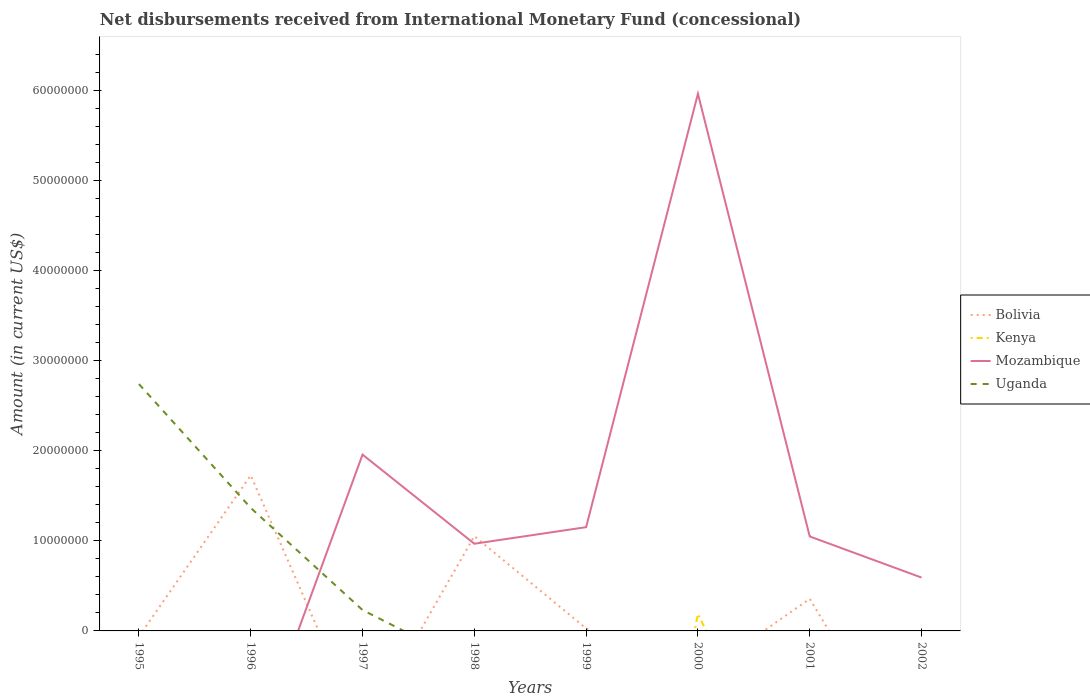What is the total amount of disbursements received from International Monetary Fund in Mozambique in the graph?
Offer a terse response. 9.89e+06. What is the difference between the highest and the second highest amount of disbursements received from International Monetary Fund in Bolivia?
Keep it short and to the point. 1.73e+07. What is the difference between the highest and the lowest amount of disbursements received from International Monetary Fund in Kenya?
Your answer should be compact. 1. Is the amount of disbursements received from International Monetary Fund in Kenya strictly greater than the amount of disbursements received from International Monetary Fund in Bolivia over the years?
Offer a very short reply. No. How many lines are there?
Your answer should be very brief. 4. How many years are there in the graph?
Ensure brevity in your answer.  8. What is the difference between two consecutive major ticks on the Y-axis?
Your answer should be compact. 1.00e+07. Are the values on the major ticks of Y-axis written in scientific E-notation?
Ensure brevity in your answer.  No. Does the graph contain grids?
Provide a succinct answer. No. How many legend labels are there?
Your answer should be very brief. 4. What is the title of the graph?
Offer a terse response. Net disbursements received from International Monetary Fund (concessional). What is the label or title of the X-axis?
Keep it short and to the point. Years. What is the label or title of the Y-axis?
Give a very brief answer. Amount (in current US$). What is the Amount (in current US$) in Bolivia in 1995?
Keep it short and to the point. 0. What is the Amount (in current US$) in Kenya in 1995?
Offer a very short reply. 0. What is the Amount (in current US$) in Mozambique in 1995?
Your answer should be very brief. 0. What is the Amount (in current US$) of Uganda in 1995?
Keep it short and to the point. 2.74e+07. What is the Amount (in current US$) in Bolivia in 1996?
Offer a very short reply. 1.73e+07. What is the Amount (in current US$) of Uganda in 1996?
Provide a succinct answer. 1.37e+07. What is the Amount (in current US$) of Bolivia in 1997?
Your answer should be compact. 0. What is the Amount (in current US$) in Mozambique in 1997?
Provide a succinct answer. 1.96e+07. What is the Amount (in current US$) of Uganda in 1997?
Ensure brevity in your answer.  2.32e+06. What is the Amount (in current US$) of Bolivia in 1998?
Your response must be concise. 1.05e+07. What is the Amount (in current US$) in Kenya in 1998?
Your answer should be compact. 0. What is the Amount (in current US$) of Mozambique in 1998?
Your response must be concise. 9.68e+06. What is the Amount (in current US$) in Uganda in 1998?
Offer a terse response. 0. What is the Amount (in current US$) of Bolivia in 1999?
Ensure brevity in your answer.  2.72e+05. What is the Amount (in current US$) of Kenya in 1999?
Your answer should be very brief. 0. What is the Amount (in current US$) in Mozambique in 1999?
Ensure brevity in your answer.  1.15e+07. What is the Amount (in current US$) in Kenya in 2000?
Give a very brief answer. 1.90e+06. What is the Amount (in current US$) of Mozambique in 2000?
Your response must be concise. 5.96e+07. What is the Amount (in current US$) of Bolivia in 2001?
Provide a succinct answer. 3.56e+06. What is the Amount (in current US$) of Mozambique in 2001?
Give a very brief answer. 1.05e+07. What is the Amount (in current US$) of Uganda in 2001?
Provide a short and direct response. 0. What is the Amount (in current US$) in Bolivia in 2002?
Make the answer very short. 0. What is the Amount (in current US$) in Kenya in 2002?
Your answer should be very brief. 0. What is the Amount (in current US$) in Mozambique in 2002?
Your answer should be very brief. 5.92e+06. Across all years, what is the maximum Amount (in current US$) in Bolivia?
Give a very brief answer. 1.73e+07. Across all years, what is the maximum Amount (in current US$) of Kenya?
Ensure brevity in your answer.  1.90e+06. Across all years, what is the maximum Amount (in current US$) in Mozambique?
Give a very brief answer. 5.96e+07. Across all years, what is the maximum Amount (in current US$) of Uganda?
Provide a succinct answer. 2.74e+07. Across all years, what is the minimum Amount (in current US$) of Kenya?
Your response must be concise. 0. What is the total Amount (in current US$) of Bolivia in the graph?
Provide a succinct answer. 3.16e+07. What is the total Amount (in current US$) in Kenya in the graph?
Provide a short and direct response. 1.90e+06. What is the total Amount (in current US$) of Mozambique in the graph?
Provide a short and direct response. 1.17e+08. What is the total Amount (in current US$) in Uganda in the graph?
Your answer should be very brief. 4.34e+07. What is the difference between the Amount (in current US$) of Uganda in 1995 and that in 1996?
Your answer should be very brief. 1.37e+07. What is the difference between the Amount (in current US$) in Uganda in 1995 and that in 1997?
Give a very brief answer. 2.51e+07. What is the difference between the Amount (in current US$) of Uganda in 1996 and that in 1997?
Ensure brevity in your answer.  1.13e+07. What is the difference between the Amount (in current US$) in Bolivia in 1996 and that in 1998?
Your answer should be compact. 6.75e+06. What is the difference between the Amount (in current US$) of Bolivia in 1996 and that in 1999?
Your answer should be compact. 1.70e+07. What is the difference between the Amount (in current US$) in Bolivia in 1996 and that in 2001?
Offer a terse response. 1.37e+07. What is the difference between the Amount (in current US$) of Mozambique in 1997 and that in 1998?
Your response must be concise. 9.89e+06. What is the difference between the Amount (in current US$) in Mozambique in 1997 and that in 1999?
Offer a terse response. 8.05e+06. What is the difference between the Amount (in current US$) of Mozambique in 1997 and that in 2000?
Ensure brevity in your answer.  -4.01e+07. What is the difference between the Amount (in current US$) in Mozambique in 1997 and that in 2001?
Provide a succinct answer. 9.08e+06. What is the difference between the Amount (in current US$) of Mozambique in 1997 and that in 2002?
Your response must be concise. 1.36e+07. What is the difference between the Amount (in current US$) of Bolivia in 1998 and that in 1999?
Keep it short and to the point. 1.02e+07. What is the difference between the Amount (in current US$) in Mozambique in 1998 and that in 1999?
Provide a short and direct response. -1.84e+06. What is the difference between the Amount (in current US$) of Mozambique in 1998 and that in 2000?
Your answer should be very brief. -4.99e+07. What is the difference between the Amount (in current US$) of Bolivia in 1998 and that in 2001?
Make the answer very short. 6.96e+06. What is the difference between the Amount (in current US$) of Mozambique in 1998 and that in 2001?
Offer a terse response. -8.08e+05. What is the difference between the Amount (in current US$) in Mozambique in 1998 and that in 2002?
Make the answer very short. 3.76e+06. What is the difference between the Amount (in current US$) in Mozambique in 1999 and that in 2000?
Offer a very short reply. -4.81e+07. What is the difference between the Amount (in current US$) in Bolivia in 1999 and that in 2001?
Give a very brief answer. -3.29e+06. What is the difference between the Amount (in current US$) of Mozambique in 1999 and that in 2001?
Your answer should be compact. 1.03e+06. What is the difference between the Amount (in current US$) of Mozambique in 1999 and that in 2002?
Give a very brief answer. 5.60e+06. What is the difference between the Amount (in current US$) of Mozambique in 2000 and that in 2001?
Make the answer very short. 4.91e+07. What is the difference between the Amount (in current US$) in Mozambique in 2000 and that in 2002?
Your answer should be compact. 5.37e+07. What is the difference between the Amount (in current US$) of Mozambique in 2001 and that in 2002?
Your answer should be compact. 4.56e+06. What is the difference between the Amount (in current US$) in Bolivia in 1996 and the Amount (in current US$) in Mozambique in 1997?
Keep it short and to the point. -2.30e+06. What is the difference between the Amount (in current US$) in Bolivia in 1996 and the Amount (in current US$) in Uganda in 1997?
Keep it short and to the point. 1.49e+07. What is the difference between the Amount (in current US$) of Bolivia in 1996 and the Amount (in current US$) of Mozambique in 1998?
Make the answer very short. 7.59e+06. What is the difference between the Amount (in current US$) of Bolivia in 1996 and the Amount (in current US$) of Mozambique in 1999?
Make the answer very short. 5.75e+06. What is the difference between the Amount (in current US$) in Bolivia in 1996 and the Amount (in current US$) in Kenya in 2000?
Offer a terse response. 1.54e+07. What is the difference between the Amount (in current US$) in Bolivia in 1996 and the Amount (in current US$) in Mozambique in 2000?
Make the answer very short. -4.24e+07. What is the difference between the Amount (in current US$) in Bolivia in 1996 and the Amount (in current US$) in Mozambique in 2001?
Offer a terse response. 6.78e+06. What is the difference between the Amount (in current US$) of Bolivia in 1996 and the Amount (in current US$) of Mozambique in 2002?
Give a very brief answer. 1.13e+07. What is the difference between the Amount (in current US$) of Bolivia in 1998 and the Amount (in current US$) of Mozambique in 1999?
Give a very brief answer. -9.98e+05. What is the difference between the Amount (in current US$) in Bolivia in 1998 and the Amount (in current US$) in Kenya in 2000?
Offer a very short reply. 8.62e+06. What is the difference between the Amount (in current US$) of Bolivia in 1998 and the Amount (in current US$) of Mozambique in 2000?
Give a very brief answer. -4.91e+07. What is the difference between the Amount (in current US$) of Bolivia in 1998 and the Amount (in current US$) of Mozambique in 2001?
Ensure brevity in your answer.  3.40e+04. What is the difference between the Amount (in current US$) in Bolivia in 1998 and the Amount (in current US$) in Mozambique in 2002?
Provide a succinct answer. 4.60e+06. What is the difference between the Amount (in current US$) of Bolivia in 1999 and the Amount (in current US$) of Kenya in 2000?
Offer a terse response. -1.62e+06. What is the difference between the Amount (in current US$) in Bolivia in 1999 and the Amount (in current US$) in Mozambique in 2000?
Ensure brevity in your answer.  -5.93e+07. What is the difference between the Amount (in current US$) of Bolivia in 1999 and the Amount (in current US$) of Mozambique in 2001?
Your response must be concise. -1.02e+07. What is the difference between the Amount (in current US$) in Bolivia in 1999 and the Amount (in current US$) in Mozambique in 2002?
Your response must be concise. -5.65e+06. What is the difference between the Amount (in current US$) in Kenya in 2000 and the Amount (in current US$) in Mozambique in 2001?
Your response must be concise. -8.59e+06. What is the difference between the Amount (in current US$) of Kenya in 2000 and the Amount (in current US$) of Mozambique in 2002?
Offer a very short reply. -4.03e+06. What is the difference between the Amount (in current US$) of Bolivia in 2001 and the Amount (in current US$) of Mozambique in 2002?
Your answer should be compact. -2.36e+06. What is the average Amount (in current US$) in Bolivia per year?
Your response must be concise. 3.95e+06. What is the average Amount (in current US$) in Kenya per year?
Give a very brief answer. 2.37e+05. What is the average Amount (in current US$) of Mozambique per year?
Your answer should be compact. 1.46e+07. What is the average Amount (in current US$) of Uganda per year?
Your answer should be compact. 5.42e+06. In the year 1996, what is the difference between the Amount (in current US$) of Bolivia and Amount (in current US$) of Uganda?
Your answer should be very brief. 3.61e+06. In the year 1997, what is the difference between the Amount (in current US$) of Mozambique and Amount (in current US$) of Uganda?
Provide a succinct answer. 1.72e+07. In the year 1998, what is the difference between the Amount (in current US$) in Bolivia and Amount (in current US$) in Mozambique?
Give a very brief answer. 8.42e+05. In the year 1999, what is the difference between the Amount (in current US$) of Bolivia and Amount (in current US$) of Mozambique?
Give a very brief answer. -1.12e+07. In the year 2000, what is the difference between the Amount (in current US$) in Kenya and Amount (in current US$) in Mozambique?
Your response must be concise. -5.77e+07. In the year 2001, what is the difference between the Amount (in current US$) of Bolivia and Amount (in current US$) of Mozambique?
Your answer should be compact. -6.92e+06. What is the ratio of the Amount (in current US$) in Uganda in 1995 to that in 1996?
Your answer should be compact. 2.01. What is the ratio of the Amount (in current US$) of Uganda in 1995 to that in 1997?
Ensure brevity in your answer.  11.81. What is the ratio of the Amount (in current US$) in Uganda in 1996 to that in 1997?
Your response must be concise. 5.88. What is the ratio of the Amount (in current US$) of Bolivia in 1996 to that in 1998?
Provide a succinct answer. 1.64. What is the ratio of the Amount (in current US$) in Bolivia in 1996 to that in 1999?
Provide a succinct answer. 63.47. What is the ratio of the Amount (in current US$) of Bolivia in 1996 to that in 2001?
Your answer should be very brief. 4.85. What is the ratio of the Amount (in current US$) of Mozambique in 1997 to that in 1998?
Keep it short and to the point. 2.02. What is the ratio of the Amount (in current US$) of Mozambique in 1997 to that in 1999?
Give a very brief answer. 1.7. What is the ratio of the Amount (in current US$) of Mozambique in 1997 to that in 2000?
Your response must be concise. 0.33. What is the ratio of the Amount (in current US$) in Mozambique in 1997 to that in 2001?
Your answer should be compact. 1.87. What is the ratio of the Amount (in current US$) in Mozambique in 1997 to that in 2002?
Your answer should be very brief. 3.3. What is the ratio of the Amount (in current US$) in Bolivia in 1998 to that in 1999?
Make the answer very short. 38.67. What is the ratio of the Amount (in current US$) of Mozambique in 1998 to that in 1999?
Ensure brevity in your answer.  0.84. What is the ratio of the Amount (in current US$) in Mozambique in 1998 to that in 2000?
Offer a terse response. 0.16. What is the ratio of the Amount (in current US$) in Bolivia in 1998 to that in 2001?
Offer a terse response. 2.95. What is the ratio of the Amount (in current US$) in Mozambique in 1998 to that in 2001?
Keep it short and to the point. 0.92. What is the ratio of the Amount (in current US$) in Mozambique in 1998 to that in 2002?
Make the answer very short. 1.63. What is the ratio of the Amount (in current US$) of Mozambique in 1999 to that in 2000?
Your answer should be compact. 0.19. What is the ratio of the Amount (in current US$) in Bolivia in 1999 to that in 2001?
Your response must be concise. 0.08. What is the ratio of the Amount (in current US$) in Mozambique in 1999 to that in 2001?
Keep it short and to the point. 1.1. What is the ratio of the Amount (in current US$) in Mozambique in 1999 to that in 2002?
Keep it short and to the point. 1.94. What is the ratio of the Amount (in current US$) of Mozambique in 2000 to that in 2001?
Keep it short and to the point. 5.69. What is the ratio of the Amount (in current US$) in Mozambique in 2000 to that in 2002?
Provide a short and direct response. 10.07. What is the ratio of the Amount (in current US$) of Mozambique in 2001 to that in 2002?
Your answer should be very brief. 1.77. What is the difference between the highest and the second highest Amount (in current US$) in Bolivia?
Your response must be concise. 6.75e+06. What is the difference between the highest and the second highest Amount (in current US$) in Mozambique?
Ensure brevity in your answer.  4.01e+07. What is the difference between the highest and the second highest Amount (in current US$) in Uganda?
Ensure brevity in your answer.  1.37e+07. What is the difference between the highest and the lowest Amount (in current US$) of Bolivia?
Your answer should be very brief. 1.73e+07. What is the difference between the highest and the lowest Amount (in current US$) in Kenya?
Your response must be concise. 1.90e+06. What is the difference between the highest and the lowest Amount (in current US$) of Mozambique?
Give a very brief answer. 5.96e+07. What is the difference between the highest and the lowest Amount (in current US$) of Uganda?
Your response must be concise. 2.74e+07. 